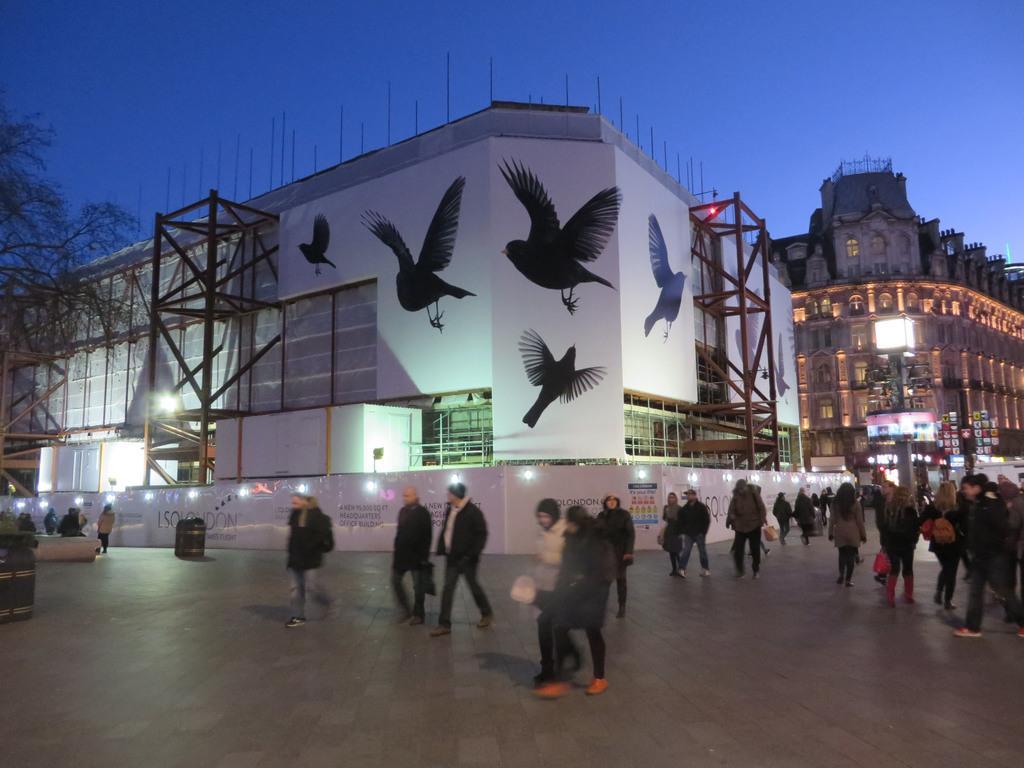Could you give a brief overview of what you see in this image? Few people are walking on this floor, in the middle it's a building, there are drawings of birds on it. In the left side it looks like a tree. 